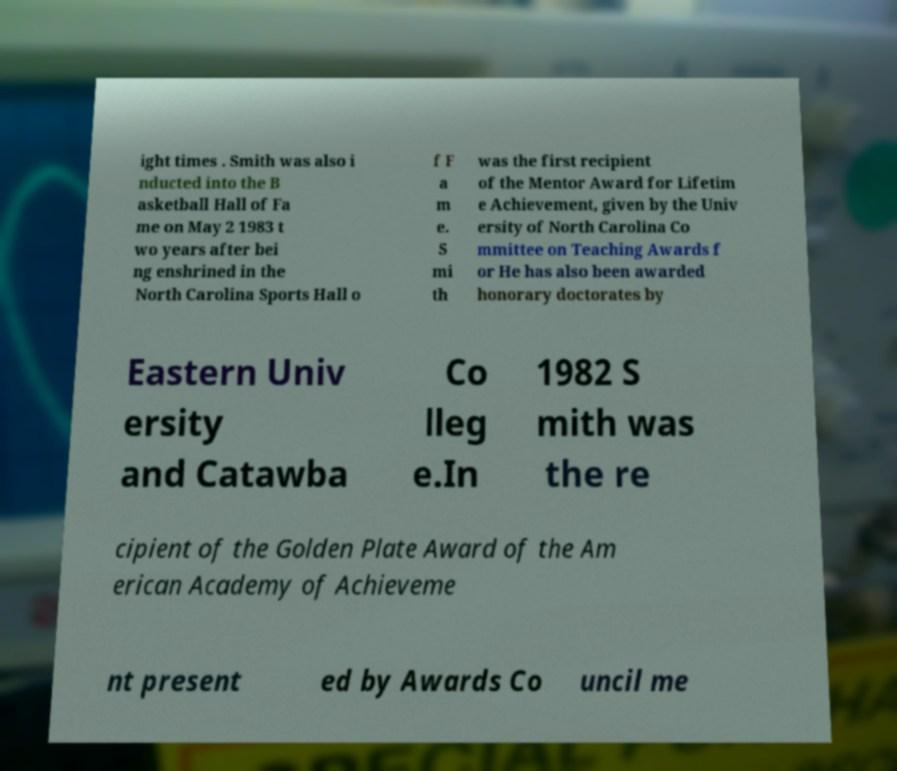There's text embedded in this image that I need extracted. Can you transcribe it verbatim? ight times . Smith was also i nducted into the B asketball Hall of Fa me on May 2 1983 t wo years after bei ng enshrined in the North Carolina Sports Hall o f F a m e. S mi th was the first recipient of the Mentor Award for Lifetim e Achievement, given by the Univ ersity of North Carolina Co mmittee on Teaching Awards f or He has also been awarded honorary doctorates by Eastern Univ ersity and Catawba Co lleg e.In 1982 S mith was the re cipient of the Golden Plate Award of the Am erican Academy of Achieveme nt present ed by Awards Co uncil me 